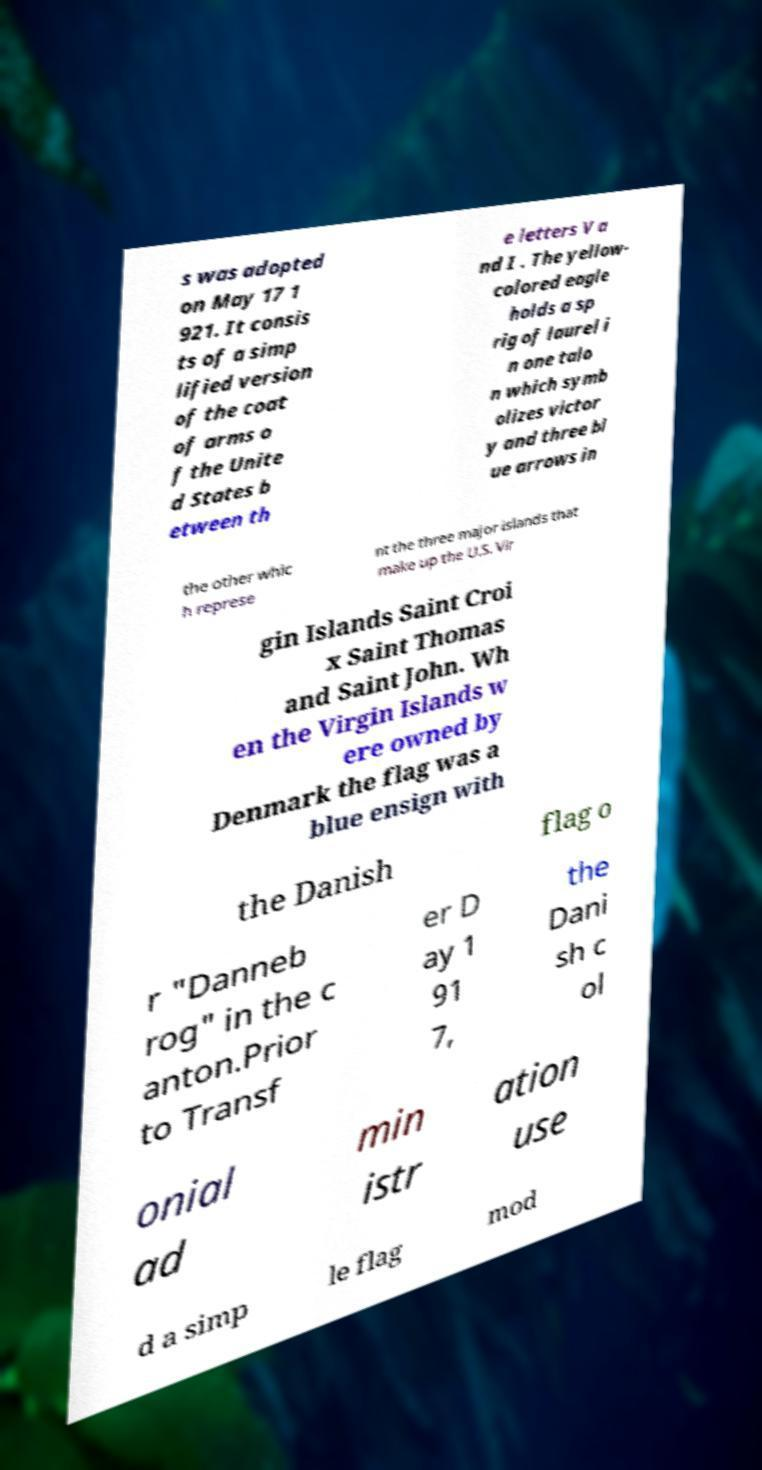Please read and relay the text visible in this image. What does it say? s was adopted on May 17 1 921. It consis ts of a simp lified version of the coat of arms o f the Unite d States b etween th e letters V a nd I . The yellow- colored eagle holds a sp rig of laurel i n one talo n which symb olizes victor y and three bl ue arrows in the other whic h represe nt the three major islands that make up the U.S. Vir gin Islands Saint Croi x Saint Thomas and Saint John. Wh en the Virgin Islands w ere owned by Denmark the flag was a blue ensign with the Danish flag o r "Danneb rog" in the c anton.Prior to Transf er D ay 1 91 7, the Dani sh c ol onial ad min istr ation use d a simp le flag mod 